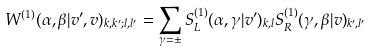<formula> <loc_0><loc_0><loc_500><loc_500>W ^ { ( 1 ) } ( \alpha , \beta | v ^ { \prime } , v ) _ { k , k ^ { \prime } ; l , l ^ { \prime } } = \sum _ { \gamma = \pm } S ^ { ( 1 ) } _ { L } ( \alpha , \gamma | v ^ { \prime } ) _ { k , l } S ^ { ( 1 ) } _ { R } ( \gamma , \beta | v ) _ { k ^ { \prime } , l ^ { \prime } }</formula> 